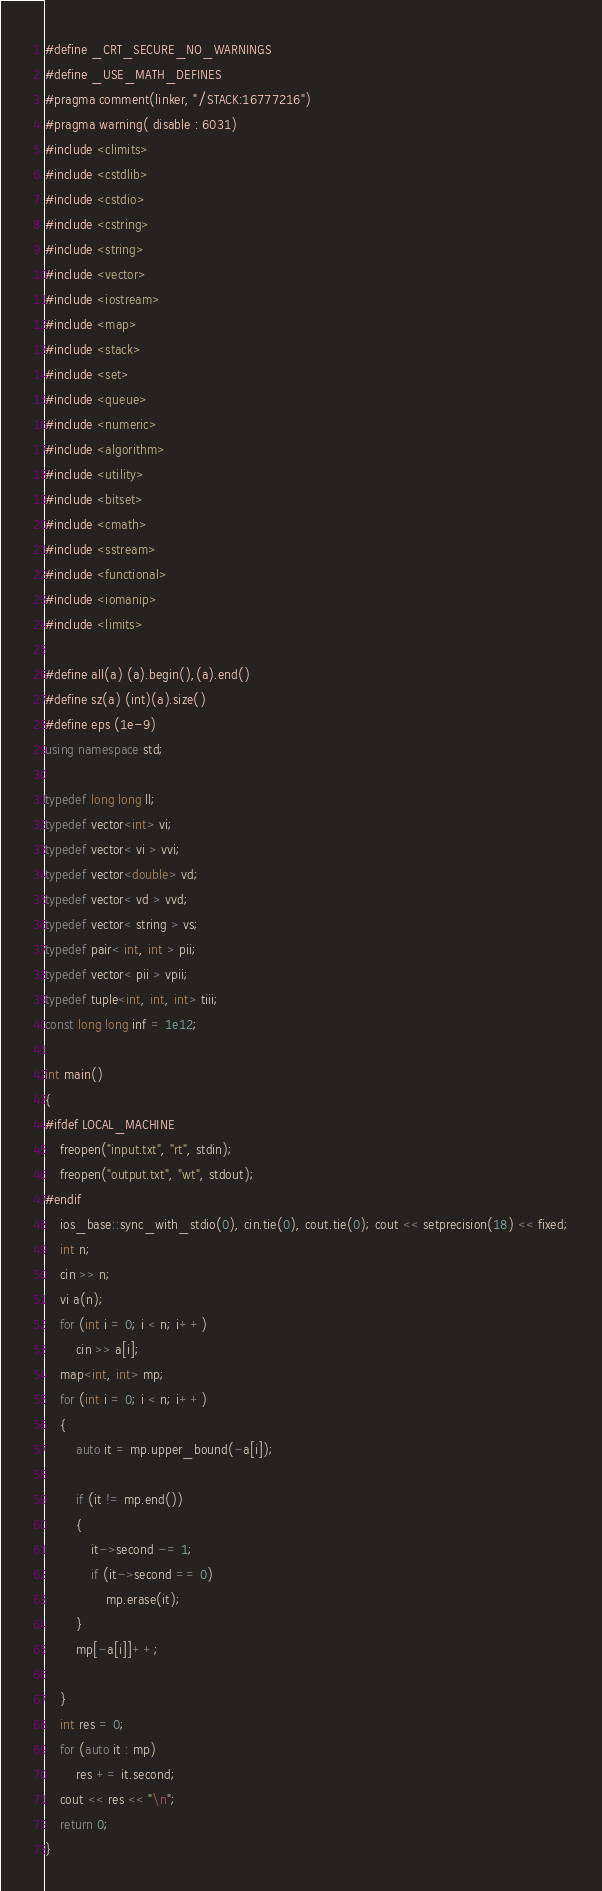<code> <loc_0><loc_0><loc_500><loc_500><_C++_>#define _CRT_SECURE_NO_WARNINGS
#define _USE_MATH_DEFINES
#pragma comment(linker, "/STACK:16777216")
#pragma warning( disable : 6031)
#include <climits>
#include <cstdlib>
#include <cstdio>
#include <cstring>
#include <string>
#include <vector>
#include <iostream>
#include <map>
#include <stack>
#include <set>
#include <queue>
#include <numeric>
#include <algorithm>
#include <utility>
#include <bitset>
#include <cmath>
#include <sstream>
#include <functional>
#include <iomanip>
#include <limits>

#define all(a) (a).begin(),(a).end()
#define sz(a) (int)(a).size()
#define eps (1e-9)
using namespace std;

typedef long long ll;
typedef vector<int> vi;
typedef vector< vi > vvi;
typedef vector<double> vd;
typedef vector< vd > vvd;
typedef vector< string > vs;
typedef pair< int, int > pii;
typedef vector< pii > vpii;
typedef tuple<int, int, int> tiii;
const long long inf = 1e12;

int main()
{
#ifdef LOCAL_MACHINE
	freopen("input.txt", "rt", stdin);
	freopen("output.txt", "wt", stdout);
#endif
	ios_base::sync_with_stdio(0), cin.tie(0), cout.tie(0); cout << setprecision(18) << fixed;
    int n;
    cin >> n;
    vi a(n);
    for (int i = 0; i < n; i++)
        cin >> a[i];
    map<int, int> mp;
    for (int i = 0; i < n; i++)
    {
        auto it = mp.upper_bound(-a[i]);

        if (it != mp.end())
        {
            it->second -= 1;
            if (it->second == 0)
                mp.erase(it);
        }
        mp[-a[i]]++;

    }
    int res = 0;
    for (auto it : mp)
        res += it.second;
    cout << res << "\n";
	return 0;
}</code> 